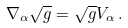Convert formula to latex. <formula><loc_0><loc_0><loc_500><loc_500>\nabla _ { \alpha } \sqrt { g } = \sqrt { g } V _ { \alpha } \, .</formula> 